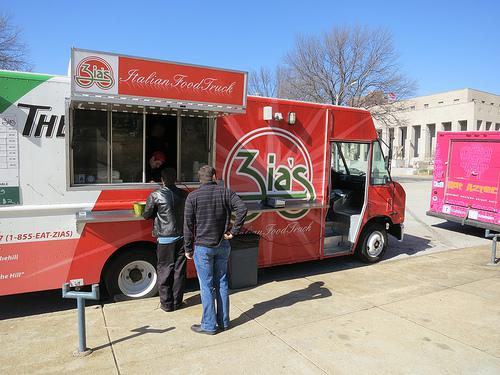Question: why are they there?
Choices:
A. To eat.
B. To sleep.
C. To play.
D. To cook.
Answer with the letter. Answer: A Question: what is on the truck?
Choices:
A. Furnitures.
B. Clothes.
C. Food.
D. Boxes.
Answer with the letter. Answer: C 